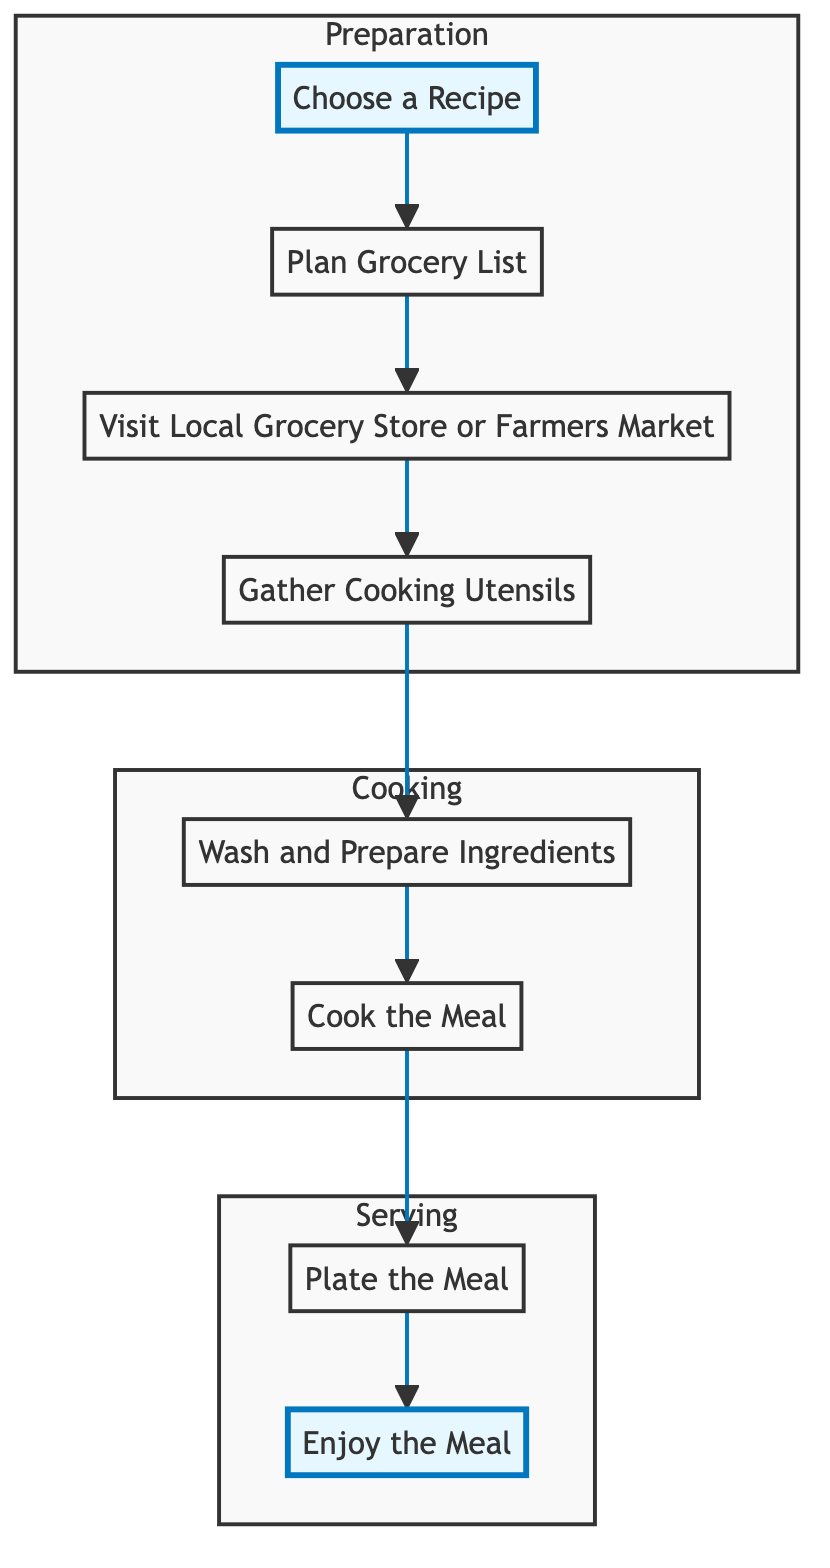What is the first step in the flow chart? The first step is indicated at the top of the Preparation section, labeled "Choose a Recipe." This denotes the initial action one must take to start the process of preparing a home-cooked meal.
Answer: Choose a Recipe How many main subgraphs are in the diagram? The diagram contains three main subgraphs: Preparation, Cooking, and Serving. Each subgraph represents a distinct phase in the overall process of meal preparation.
Answer: Three Which step immediately follows 'Gather Cooking Utensils'? By tracing the arrow from the node "Gather Cooking Utensils," the next step is "Wash and Prepare Ingredients." This follows sequentially in the preparation process.
Answer: Wash and Prepare Ingredients What color represents the Cooking section of the flow chart? The Cooking section is filled with a green color, as indicated by the style associated with that subgraph. This color visually distinguishes it from the other phases.
Answer: Green Which step is labeled as the final action in the flow chart? The last step in the flow chart, marked at the bottom of the Serving subgraph, is "Enjoy the Meal." This signifies the culmination of the meal preparation process.
Answer: Enjoy the Meal In which subgraph does 'Plate the Meal' reside? "Plate the Meal" can be found within the Serving subgraph. This categorizes it as part of the actions taken after cooking, focused on serving the meal.
Answer: Serving How many steps are in the Preparation subgraph? The Preparation subgraph includes four steps: "Choose a Recipe," "Plan Grocery List," "Visit Local Grocery Store or Farmers Market," and "Gather Cooking Utensils." These indicate each action within that phase.
Answer: Four Which two steps directly connect the Cooking and Serving subgraphs? The two steps that connect Cooking and Serving are "Cook the Meal" and "Plate the Meal." "Cook the Meal" transitions to "Plate the Meal" as part of completing the meal preparation process.
Answer: Cook the Meal, Plate the Meal What is the primary action in the Cooking subgraph? The primary action in the Cooking subgraph is "Cook the Meal." This activity represents the essential cooking process after all preparations have been made.
Answer: Cook the Meal 